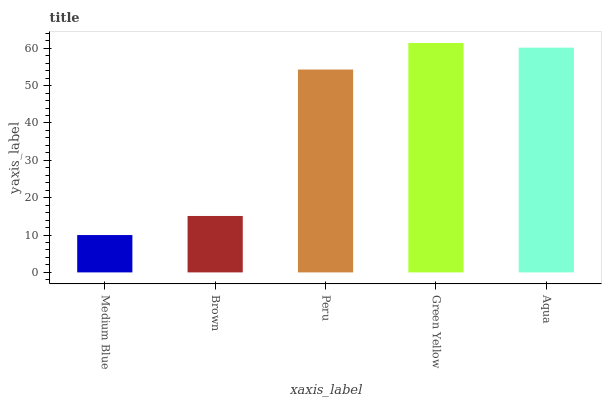Is Medium Blue the minimum?
Answer yes or no. Yes. Is Green Yellow the maximum?
Answer yes or no. Yes. Is Brown the minimum?
Answer yes or no. No. Is Brown the maximum?
Answer yes or no. No. Is Brown greater than Medium Blue?
Answer yes or no. Yes. Is Medium Blue less than Brown?
Answer yes or no. Yes. Is Medium Blue greater than Brown?
Answer yes or no. No. Is Brown less than Medium Blue?
Answer yes or no. No. Is Peru the high median?
Answer yes or no. Yes. Is Peru the low median?
Answer yes or no. Yes. Is Aqua the high median?
Answer yes or no. No. Is Brown the low median?
Answer yes or no. No. 